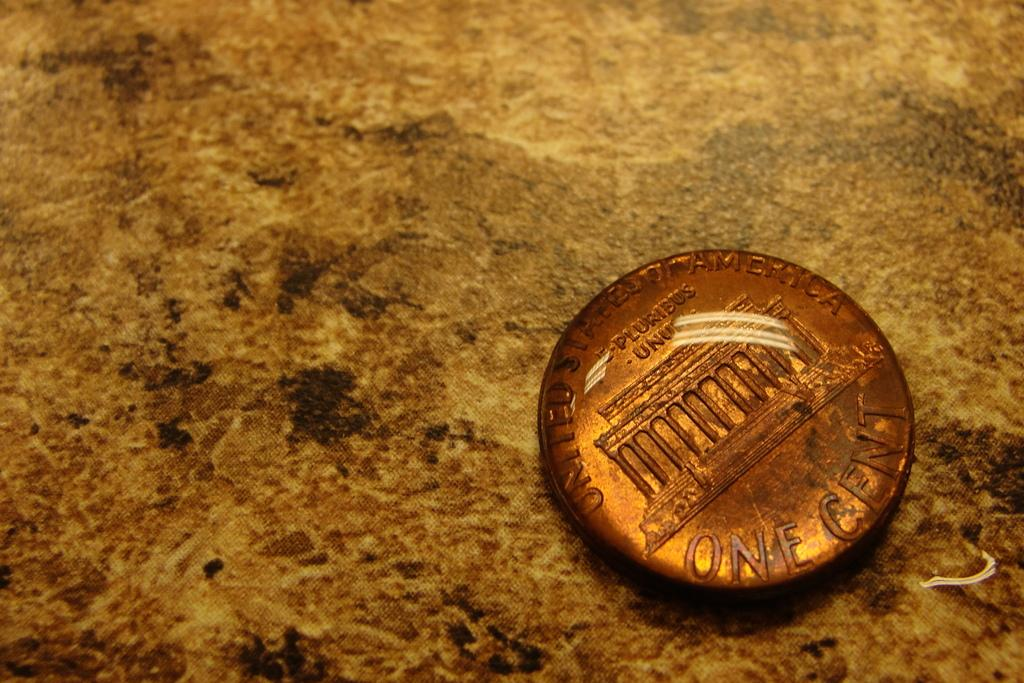<image>
Render a clear and concise summary of the photo. A one cent coin has E Pluribus Unum in latin on the front. 